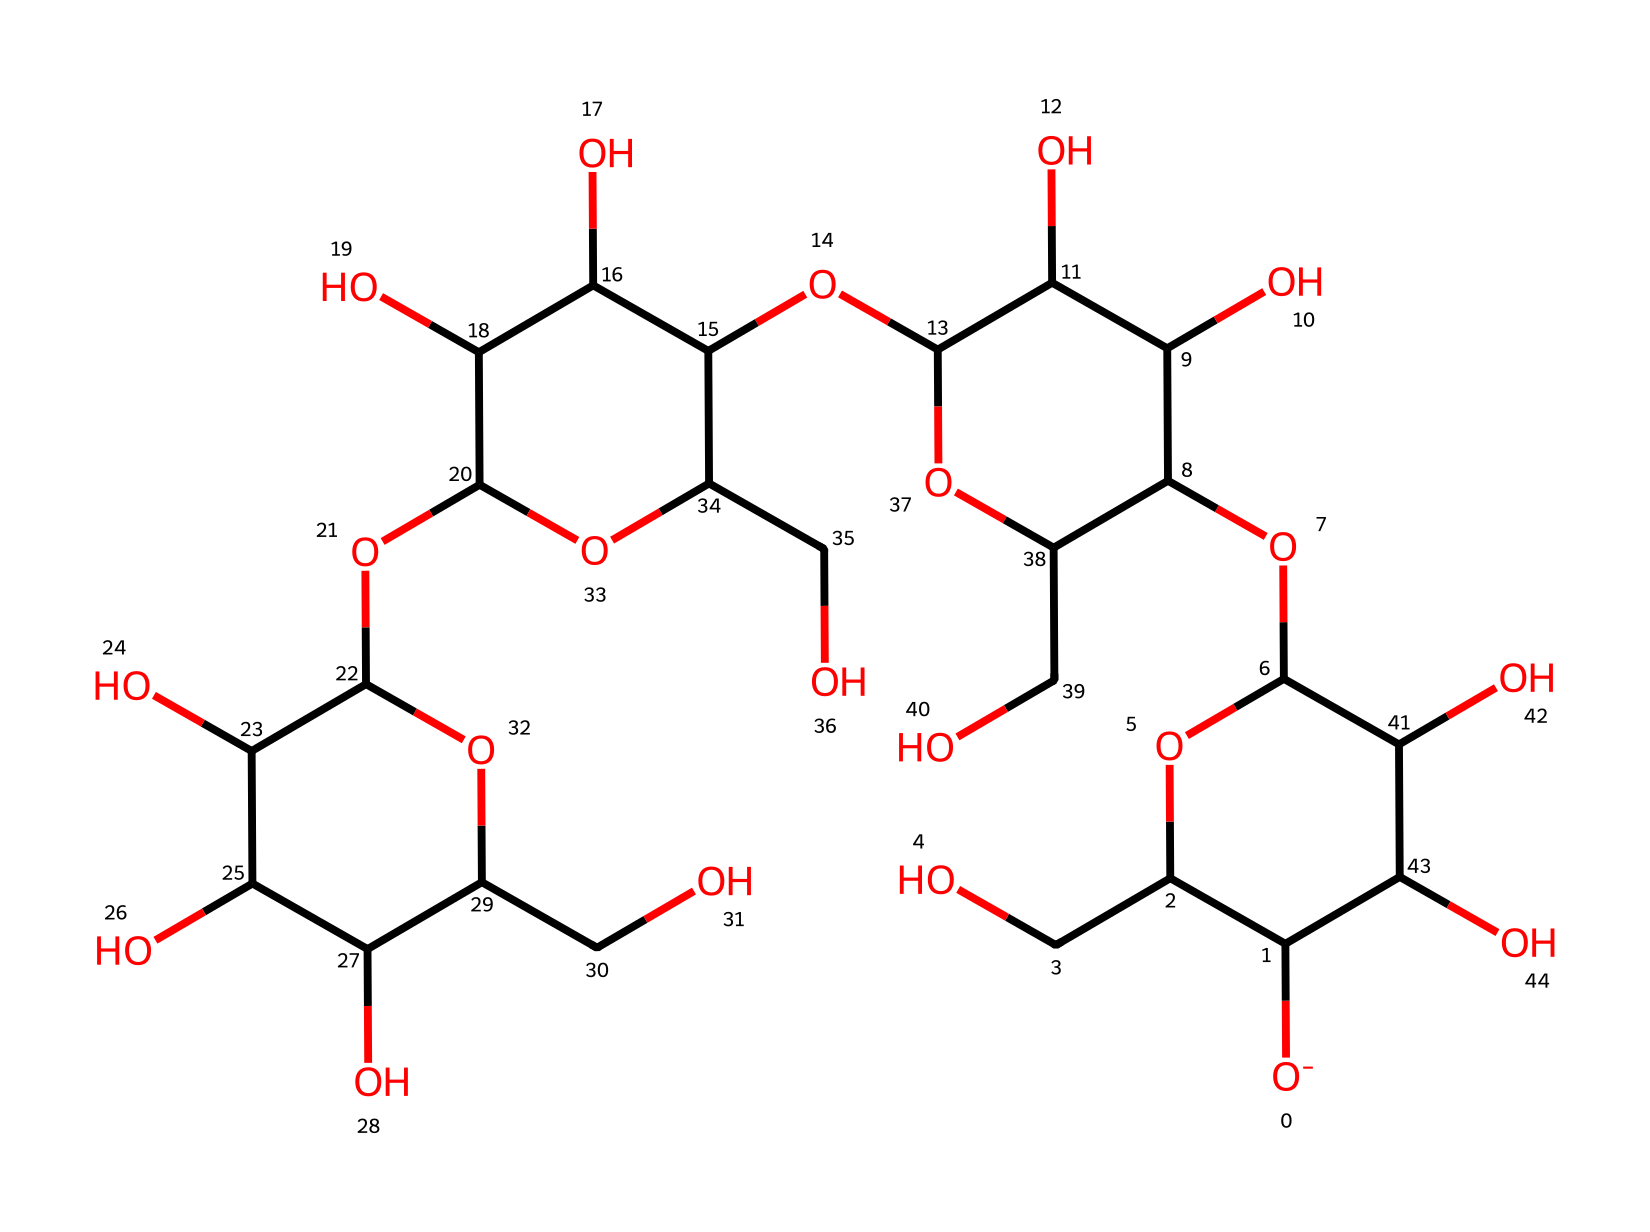What is the molecular formula of cellulose? By analyzing the SMILES representation, we can count carbon (C), hydrogen (H), and oxygen (O) atoms. This structure contains 6 carbon atoms in each repeating unit, and there are multiple repeating units (glucose units in cellulose). From the count, the molecular formula can be derived as C6H10O5 for each unit.
Answer: C6H10O5 How many monomeric units compose this structure? The structure contains multiple rings representing glucose units. Each glucose unit counts as a monomer. By counting the number of ring structures in the SMILES, we find that there are four glucose monomers present.
Answer: four What type of glycosidic linkage is present in cellulose? Cellulose is composed of glucose units linked by β(1→4) glycosidic bonds. This can be inferred from the arrangement of the hydroxyl (-OH) groups in the structure.
Answer: β(1→4) What is the degree of polymerization in this structure? The degree of polymerization refers to the number of monomeric units in the polymer. As previously identified, there are four glucose units in this specific structure, which gives the degree of polymerization as four.
Answer: four What functional groups are present in cellulose? Looking through the structure, several functional groups such as hydroxyl groups (-OH) are present throughout the molecule, which are characteristic of cellulose and contribute to its physical properties.
Answer: hydroxyl groups 